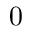<formula> <loc_0><loc_0><loc_500><loc_500>0</formula> 